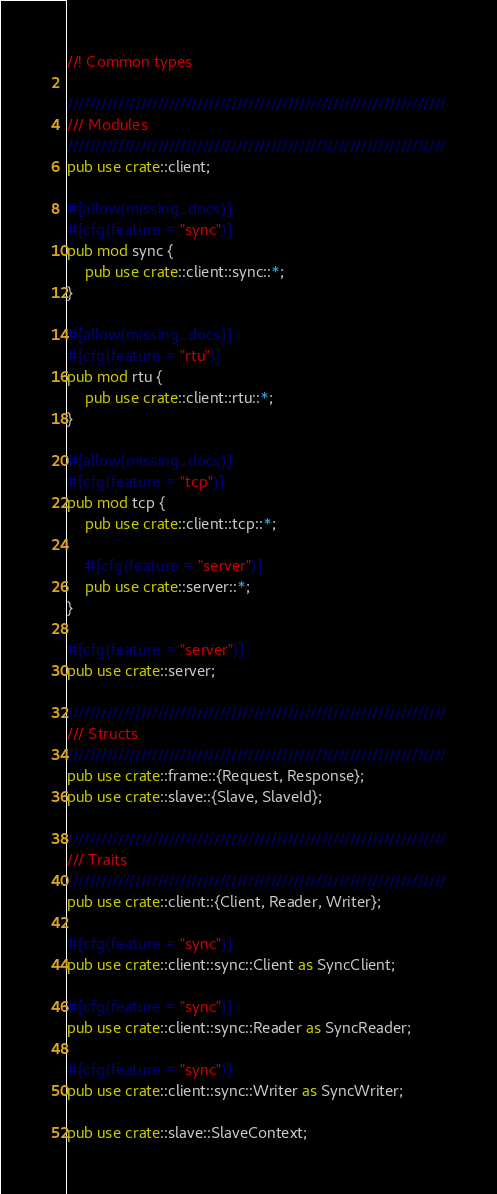Convert code to text. <code><loc_0><loc_0><loc_500><loc_500><_Rust_>//! Common types

///////////////////////////////////////////////////////////////////
/// Modules
///////////////////////////////////////////////////////////////////
pub use crate::client;

#[allow(missing_docs)]
#[cfg(feature = "sync")]
pub mod sync {
    pub use crate::client::sync::*;
}

#[allow(missing_docs)]
#[cfg(feature = "rtu")]
pub mod rtu {
    pub use crate::client::rtu::*;
}

#[allow(missing_docs)]
#[cfg(feature = "tcp")]
pub mod tcp {
    pub use crate::client::tcp::*;

    #[cfg(feature = "server")]
    pub use crate::server::*;
}

#[cfg(feature = "server")]
pub use crate::server;

///////////////////////////////////////////////////////////////////
/// Structs
///////////////////////////////////////////////////////////////////
pub use crate::frame::{Request, Response};
pub use crate::slave::{Slave, SlaveId};

///////////////////////////////////////////////////////////////////
/// Traits
///////////////////////////////////////////////////////////////////
pub use crate::client::{Client, Reader, Writer};

#[cfg(feature = "sync")]
pub use crate::client::sync::Client as SyncClient;

#[cfg(feature = "sync")]
pub use crate::client::sync::Reader as SyncReader;

#[cfg(feature = "sync")]
pub use crate::client::sync::Writer as SyncWriter;

pub use crate::slave::SlaveContext;
</code> 